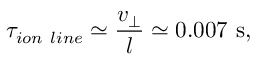Convert formula to latex. <formula><loc_0><loc_0><loc_500><loc_500>\tau _ { i o n l i n e } \simeq \frac { v _ { \perp } } { l } \simeq 0 . 0 0 7 s ,</formula> 